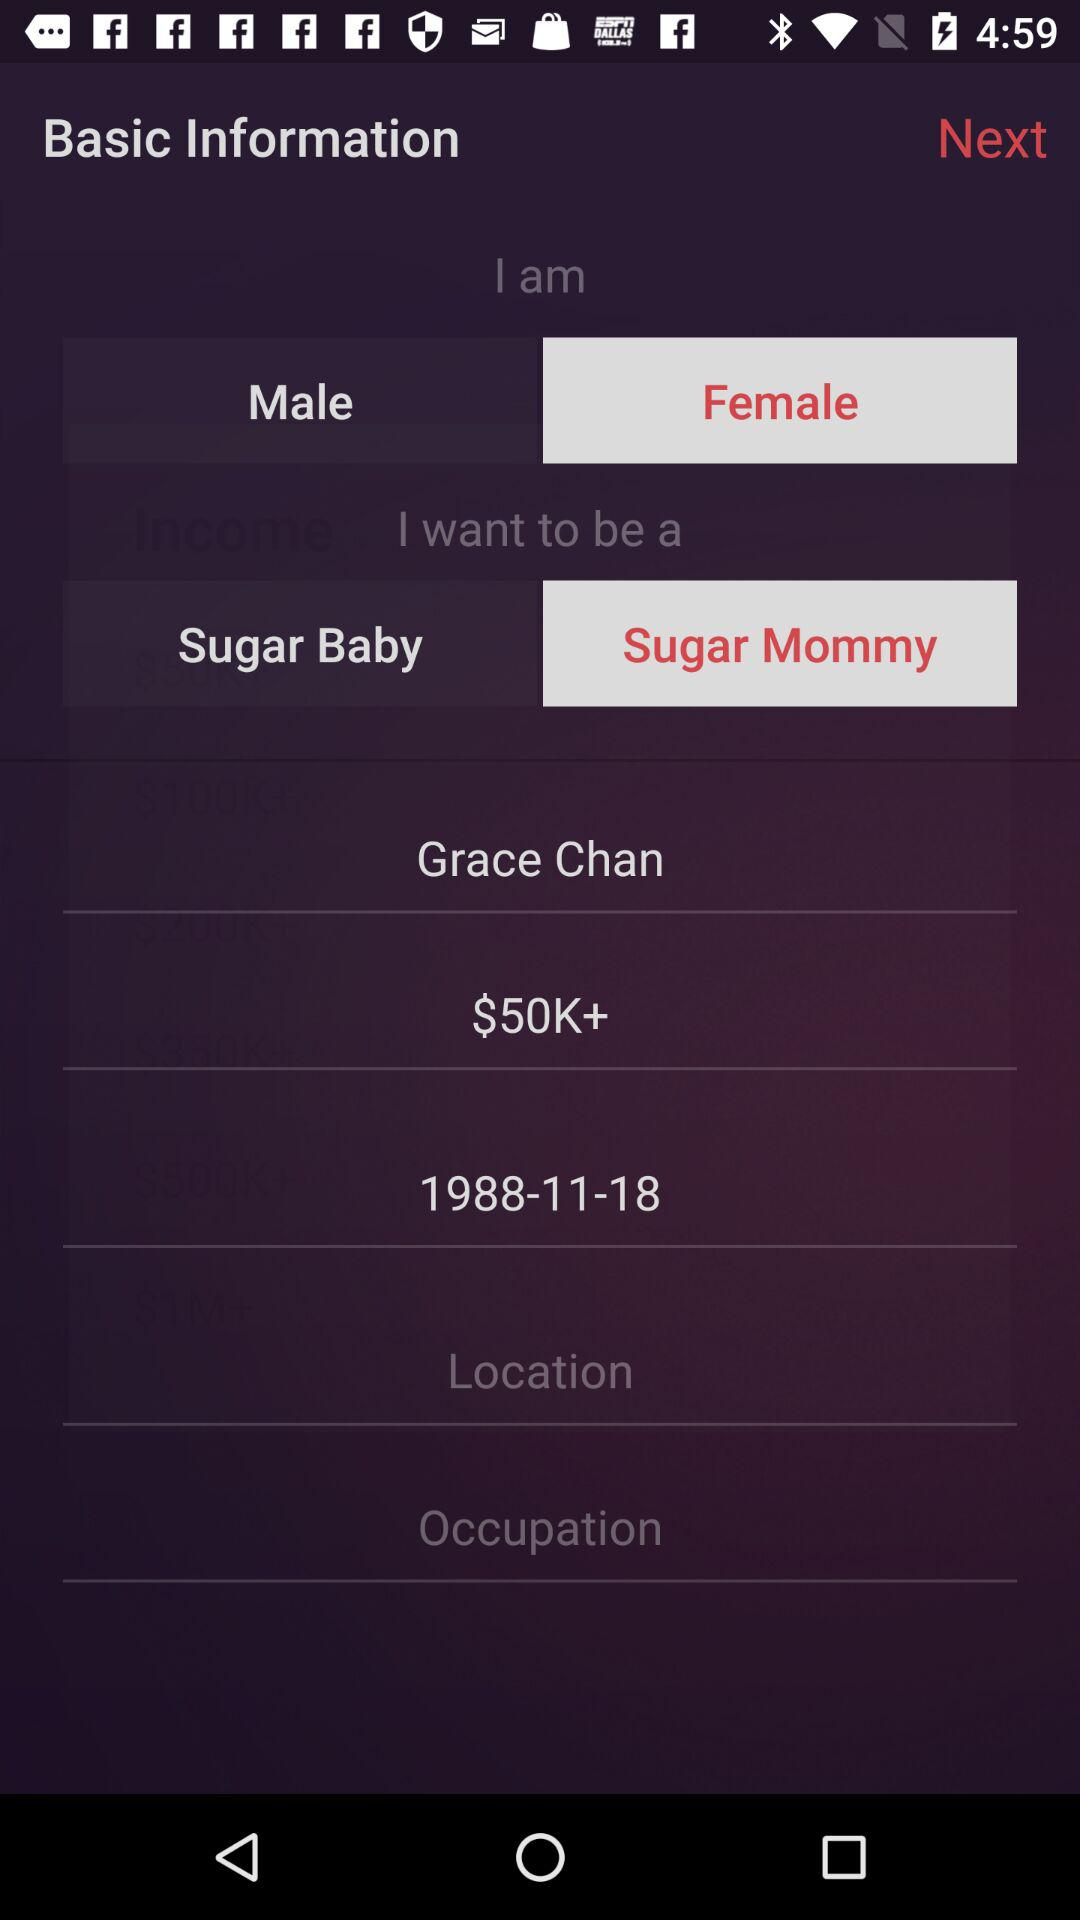What is the name? The name is Grace Chan. 